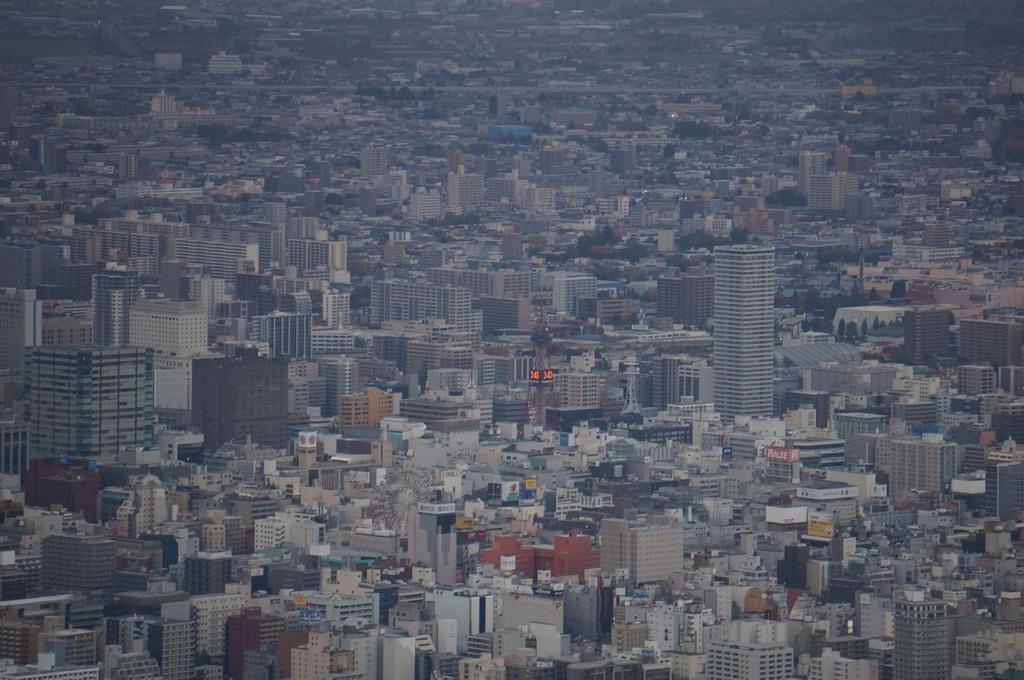In one or two sentences, can you explain what this image depicts? In the picture we can see an Aerial view of the city with full of buildings and the tower buildings with many floors. 